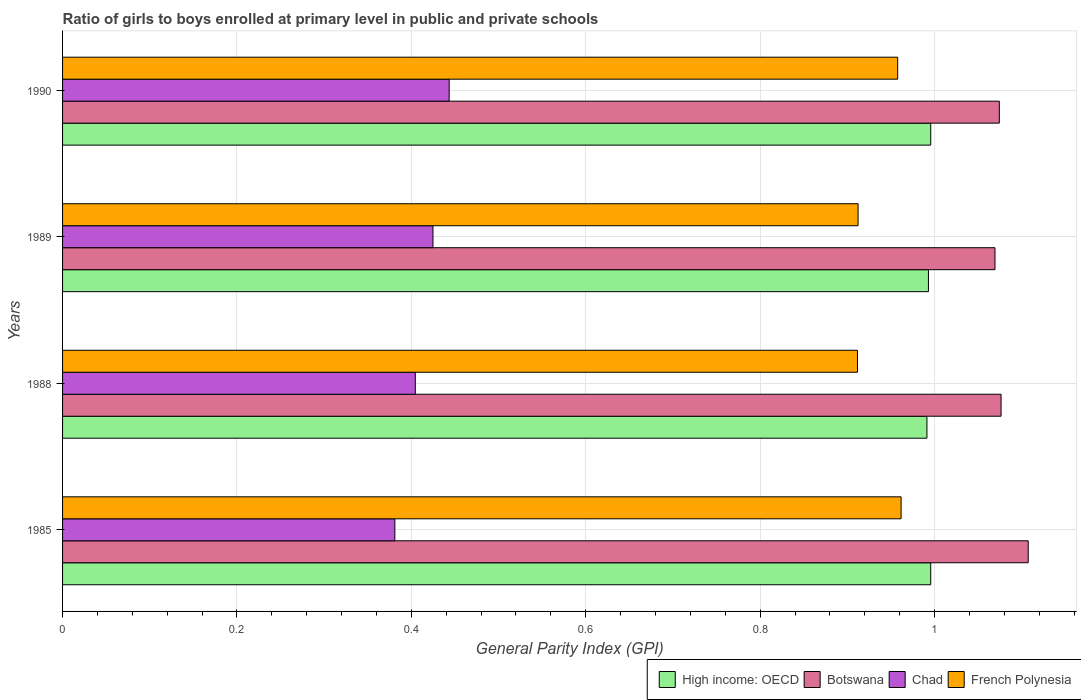How many different coloured bars are there?
Make the answer very short. 4. Are the number of bars per tick equal to the number of legend labels?
Offer a very short reply. Yes. Are the number of bars on each tick of the Y-axis equal?
Ensure brevity in your answer.  Yes. How many bars are there on the 1st tick from the bottom?
Provide a short and direct response. 4. In how many cases, is the number of bars for a given year not equal to the number of legend labels?
Make the answer very short. 0. What is the general parity index in Chad in 1985?
Provide a short and direct response. 0.38. Across all years, what is the maximum general parity index in Chad?
Give a very brief answer. 0.44. Across all years, what is the minimum general parity index in French Polynesia?
Offer a very short reply. 0.91. What is the total general parity index in Chad in the graph?
Make the answer very short. 1.65. What is the difference between the general parity index in Botswana in 1985 and that in 1990?
Provide a short and direct response. 0.03. What is the difference between the general parity index in Chad in 1988 and the general parity index in Botswana in 1985?
Your response must be concise. -0.7. What is the average general parity index in Botswana per year?
Offer a terse response. 1.08. In the year 1985, what is the difference between the general parity index in Botswana and general parity index in Chad?
Offer a terse response. 0.73. What is the ratio of the general parity index in Botswana in 1989 to that in 1990?
Provide a succinct answer. 1. What is the difference between the highest and the second highest general parity index in Chad?
Provide a short and direct response. 0.02. What is the difference between the highest and the lowest general parity index in French Polynesia?
Your answer should be very brief. 0.05. In how many years, is the general parity index in Botswana greater than the average general parity index in Botswana taken over all years?
Your response must be concise. 1. Is it the case that in every year, the sum of the general parity index in High income: OECD and general parity index in French Polynesia is greater than the sum of general parity index in Botswana and general parity index in Chad?
Make the answer very short. Yes. What does the 1st bar from the top in 1990 represents?
Provide a succinct answer. French Polynesia. What does the 4th bar from the bottom in 1989 represents?
Provide a succinct answer. French Polynesia. Is it the case that in every year, the sum of the general parity index in Chad and general parity index in Botswana is greater than the general parity index in High income: OECD?
Make the answer very short. Yes. Are all the bars in the graph horizontal?
Keep it short and to the point. Yes. What is the difference between two consecutive major ticks on the X-axis?
Your response must be concise. 0.2. Are the values on the major ticks of X-axis written in scientific E-notation?
Keep it short and to the point. No. Does the graph contain grids?
Give a very brief answer. Yes. Where does the legend appear in the graph?
Offer a very short reply. Bottom right. How many legend labels are there?
Your answer should be very brief. 4. What is the title of the graph?
Ensure brevity in your answer.  Ratio of girls to boys enrolled at primary level in public and private schools. Does "Macao" appear as one of the legend labels in the graph?
Your response must be concise. No. What is the label or title of the X-axis?
Your response must be concise. General Parity Index (GPI). What is the label or title of the Y-axis?
Give a very brief answer. Years. What is the General Parity Index (GPI) of High income: OECD in 1985?
Make the answer very short. 1. What is the General Parity Index (GPI) of Botswana in 1985?
Give a very brief answer. 1.11. What is the General Parity Index (GPI) of Chad in 1985?
Make the answer very short. 0.38. What is the General Parity Index (GPI) of French Polynesia in 1985?
Give a very brief answer. 0.96. What is the General Parity Index (GPI) of High income: OECD in 1988?
Your answer should be compact. 0.99. What is the General Parity Index (GPI) in Botswana in 1988?
Make the answer very short. 1.08. What is the General Parity Index (GPI) of Chad in 1988?
Provide a succinct answer. 0.4. What is the General Parity Index (GPI) in French Polynesia in 1988?
Make the answer very short. 0.91. What is the General Parity Index (GPI) of High income: OECD in 1989?
Your response must be concise. 0.99. What is the General Parity Index (GPI) in Botswana in 1989?
Your answer should be compact. 1.07. What is the General Parity Index (GPI) in Chad in 1989?
Keep it short and to the point. 0.42. What is the General Parity Index (GPI) of French Polynesia in 1989?
Offer a terse response. 0.91. What is the General Parity Index (GPI) of High income: OECD in 1990?
Your response must be concise. 1. What is the General Parity Index (GPI) of Botswana in 1990?
Offer a very short reply. 1.07. What is the General Parity Index (GPI) in Chad in 1990?
Offer a very short reply. 0.44. What is the General Parity Index (GPI) of French Polynesia in 1990?
Provide a short and direct response. 0.96. Across all years, what is the maximum General Parity Index (GPI) in High income: OECD?
Your answer should be compact. 1. Across all years, what is the maximum General Parity Index (GPI) of Botswana?
Provide a short and direct response. 1.11. Across all years, what is the maximum General Parity Index (GPI) in Chad?
Provide a short and direct response. 0.44. Across all years, what is the maximum General Parity Index (GPI) in French Polynesia?
Offer a terse response. 0.96. Across all years, what is the minimum General Parity Index (GPI) in High income: OECD?
Offer a terse response. 0.99. Across all years, what is the minimum General Parity Index (GPI) of Botswana?
Your answer should be very brief. 1.07. Across all years, what is the minimum General Parity Index (GPI) in Chad?
Give a very brief answer. 0.38. Across all years, what is the minimum General Parity Index (GPI) in French Polynesia?
Your answer should be very brief. 0.91. What is the total General Parity Index (GPI) of High income: OECD in the graph?
Give a very brief answer. 3.98. What is the total General Parity Index (GPI) in Botswana in the graph?
Offer a very short reply. 4.33. What is the total General Parity Index (GPI) of Chad in the graph?
Ensure brevity in your answer.  1.65. What is the total General Parity Index (GPI) in French Polynesia in the graph?
Your answer should be very brief. 3.74. What is the difference between the General Parity Index (GPI) in High income: OECD in 1985 and that in 1988?
Keep it short and to the point. 0. What is the difference between the General Parity Index (GPI) of Botswana in 1985 and that in 1988?
Your answer should be compact. 0.03. What is the difference between the General Parity Index (GPI) of Chad in 1985 and that in 1988?
Provide a short and direct response. -0.02. What is the difference between the General Parity Index (GPI) of French Polynesia in 1985 and that in 1988?
Keep it short and to the point. 0.05. What is the difference between the General Parity Index (GPI) in High income: OECD in 1985 and that in 1989?
Provide a succinct answer. 0. What is the difference between the General Parity Index (GPI) in Botswana in 1985 and that in 1989?
Your answer should be compact. 0.04. What is the difference between the General Parity Index (GPI) of Chad in 1985 and that in 1989?
Your response must be concise. -0.04. What is the difference between the General Parity Index (GPI) of French Polynesia in 1985 and that in 1989?
Make the answer very short. 0.05. What is the difference between the General Parity Index (GPI) in High income: OECD in 1985 and that in 1990?
Your answer should be compact. -0. What is the difference between the General Parity Index (GPI) in Botswana in 1985 and that in 1990?
Provide a short and direct response. 0.03. What is the difference between the General Parity Index (GPI) in Chad in 1985 and that in 1990?
Offer a very short reply. -0.06. What is the difference between the General Parity Index (GPI) of French Polynesia in 1985 and that in 1990?
Ensure brevity in your answer.  0. What is the difference between the General Parity Index (GPI) of High income: OECD in 1988 and that in 1989?
Your answer should be compact. -0. What is the difference between the General Parity Index (GPI) of Botswana in 1988 and that in 1989?
Ensure brevity in your answer.  0.01. What is the difference between the General Parity Index (GPI) of Chad in 1988 and that in 1989?
Your response must be concise. -0.02. What is the difference between the General Parity Index (GPI) of French Polynesia in 1988 and that in 1989?
Your answer should be compact. -0. What is the difference between the General Parity Index (GPI) in High income: OECD in 1988 and that in 1990?
Ensure brevity in your answer.  -0. What is the difference between the General Parity Index (GPI) of Botswana in 1988 and that in 1990?
Your response must be concise. 0. What is the difference between the General Parity Index (GPI) of Chad in 1988 and that in 1990?
Ensure brevity in your answer.  -0.04. What is the difference between the General Parity Index (GPI) in French Polynesia in 1988 and that in 1990?
Provide a short and direct response. -0.05. What is the difference between the General Parity Index (GPI) in High income: OECD in 1989 and that in 1990?
Make the answer very short. -0. What is the difference between the General Parity Index (GPI) in Botswana in 1989 and that in 1990?
Ensure brevity in your answer.  -0.01. What is the difference between the General Parity Index (GPI) of Chad in 1989 and that in 1990?
Make the answer very short. -0.02. What is the difference between the General Parity Index (GPI) in French Polynesia in 1989 and that in 1990?
Provide a succinct answer. -0.05. What is the difference between the General Parity Index (GPI) in High income: OECD in 1985 and the General Parity Index (GPI) in Botswana in 1988?
Offer a very short reply. -0.08. What is the difference between the General Parity Index (GPI) in High income: OECD in 1985 and the General Parity Index (GPI) in Chad in 1988?
Your response must be concise. 0.59. What is the difference between the General Parity Index (GPI) of High income: OECD in 1985 and the General Parity Index (GPI) of French Polynesia in 1988?
Your answer should be very brief. 0.08. What is the difference between the General Parity Index (GPI) in Botswana in 1985 and the General Parity Index (GPI) in Chad in 1988?
Your answer should be very brief. 0.7. What is the difference between the General Parity Index (GPI) in Botswana in 1985 and the General Parity Index (GPI) in French Polynesia in 1988?
Your response must be concise. 0.2. What is the difference between the General Parity Index (GPI) of Chad in 1985 and the General Parity Index (GPI) of French Polynesia in 1988?
Your response must be concise. -0.53. What is the difference between the General Parity Index (GPI) in High income: OECD in 1985 and the General Parity Index (GPI) in Botswana in 1989?
Make the answer very short. -0.07. What is the difference between the General Parity Index (GPI) of High income: OECD in 1985 and the General Parity Index (GPI) of Chad in 1989?
Give a very brief answer. 0.57. What is the difference between the General Parity Index (GPI) of High income: OECD in 1985 and the General Parity Index (GPI) of French Polynesia in 1989?
Your answer should be very brief. 0.08. What is the difference between the General Parity Index (GPI) in Botswana in 1985 and the General Parity Index (GPI) in Chad in 1989?
Provide a succinct answer. 0.68. What is the difference between the General Parity Index (GPI) of Botswana in 1985 and the General Parity Index (GPI) of French Polynesia in 1989?
Offer a terse response. 0.2. What is the difference between the General Parity Index (GPI) in Chad in 1985 and the General Parity Index (GPI) in French Polynesia in 1989?
Provide a short and direct response. -0.53. What is the difference between the General Parity Index (GPI) in High income: OECD in 1985 and the General Parity Index (GPI) in Botswana in 1990?
Keep it short and to the point. -0.08. What is the difference between the General Parity Index (GPI) in High income: OECD in 1985 and the General Parity Index (GPI) in Chad in 1990?
Provide a short and direct response. 0.55. What is the difference between the General Parity Index (GPI) of High income: OECD in 1985 and the General Parity Index (GPI) of French Polynesia in 1990?
Keep it short and to the point. 0.04. What is the difference between the General Parity Index (GPI) of Botswana in 1985 and the General Parity Index (GPI) of Chad in 1990?
Offer a terse response. 0.66. What is the difference between the General Parity Index (GPI) of Botswana in 1985 and the General Parity Index (GPI) of French Polynesia in 1990?
Your answer should be very brief. 0.15. What is the difference between the General Parity Index (GPI) in Chad in 1985 and the General Parity Index (GPI) in French Polynesia in 1990?
Offer a terse response. -0.58. What is the difference between the General Parity Index (GPI) of High income: OECD in 1988 and the General Parity Index (GPI) of Botswana in 1989?
Make the answer very short. -0.08. What is the difference between the General Parity Index (GPI) of High income: OECD in 1988 and the General Parity Index (GPI) of Chad in 1989?
Give a very brief answer. 0.57. What is the difference between the General Parity Index (GPI) in High income: OECD in 1988 and the General Parity Index (GPI) in French Polynesia in 1989?
Your answer should be very brief. 0.08. What is the difference between the General Parity Index (GPI) of Botswana in 1988 and the General Parity Index (GPI) of Chad in 1989?
Your answer should be very brief. 0.65. What is the difference between the General Parity Index (GPI) in Botswana in 1988 and the General Parity Index (GPI) in French Polynesia in 1989?
Offer a very short reply. 0.16. What is the difference between the General Parity Index (GPI) in Chad in 1988 and the General Parity Index (GPI) in French Polynesia in 1989?
Ensure brevity in your answer.  -0.51. What is the difference between the General Parity Index (GPI) of High income: OECD in 1988 and the General Parity Index (GPI) of Botswana in 1990?
Your answer should be very brief. -0.08. What is the difference between the General Parity Index (GPI) in High income: OECD in 1988 and the General Parity Index (GPI) in Chad in 1990?
Provide a succinct answer. 0.55. What is the difference between the General Parity Index (GPI) of High income: OECD in 1988 and the General Parity Index (GPI) of French Polynesia in 1990?
Provide a succinct answer. 0.03. What is the difference between the General Parity Index (GPI) in Botswana in 1988 and the General Parity Index (GPI) in Chad in 1990?
Keep it short and to the point. 0.63. What is the difference between the General Parity Index (GPI) in Botswana in 1988 and the General Parity Index (GPI) in French Polynesia in 1990?
Provide a succinct answer. 0.12. What is the difference between the General Parity Index (GPI) in Chad in 1988 and the General Parity Index (GPI) in French Polynesia in 1990?
Your answer should be compact. -0.55. What is the difference between the General Parity Index (GPI) in High income: OECD in 1989 and the General Parity Index (GPI) in Botswana in 1990?
Provide a short and direct response. -0.08. What is the difference between the General Parity Index (GPI) in High income: OECD in 1989 and the General Parity Index (GPI) in Chad in 1990?
Provide a succinct answer. 0.55. What is the difference between the General Parity Index (GPI) of High income: OECD in 1989 and the General Parity Index (GPI) of French Polynesia in 1990?
Provide a succinct answer. 0.04. What is the difference between the General Parity Index (GPI) of Botswana in 1989 and the General Parity Index (GPI) of Chad in 1990?
Your answer should be very brief. 0.63. What is the difference between the General Parity Index (GPI) of Botswana in 1989 and the General Parity Index (GPI) of French Polynesia in 1990?
Give a very brief answer. 0.11. What is the difference between the General Parity Index (GPI) of Chad in 1989 and the General Parity Index (GPI) of French Polynesia in 1990?
Give a very brief answer. -0.53. What is the average General Parity Index (GPI) in High income: OECD per year?
Your response must be concise. 0.99. What is the average General Parity Index (GPI) in Botswana per year?
Provide a succinct answer. 1.08. What is the average General Parity Index (GPI) in Chad per year?
Provide a short and direct response. 0.41. What is the average General Parity Index (GPI) in French Polynesia per year?
Offer a terse response. 0.94. In the year 1985, what is the difference between the General Parity Index (GPI) of High income: OECD and General Parity Index (GPI) of Botswana?
Offer a very short reply. -0.11. In the year 1985, what is the difference between the General Parity Index (GPI) of High income: OECD and General Parity Index (GPI) of Chad?
Offer a terse response. 0.61. In the year 1985, what is the difference between the General Parity Index (GPI) of High income: OECD and General Parity Index (GPI) of French Polynesia?
Make the answer very short. 0.03. In the year 1985, what is the difference between the General Parity Index (GPI) of Botswana and General Parity Index (GPI) of Chad?
Make the answer very short. 0.73. In the year 1985, what is the difference between the General Parity Index (GPI) in Botswana and General Parity Index (GPI) in French Polynesia?
Ensure brevity in your answer.  0.15. In the year 1985, what is the difference between the General Parity Index (GPI) of Chad and General Parity Index (GPI) of French Polynesia?
Your answer should be compact. -0.58. In the year 1988, what is the difference between the General Parity Index (GPI) of High income: OECD and General Parity Index (GPI) of Botswana?
Offer a terse response. -0.09. In the year 1988, what is the difference between the General Parity Index (GPI) of High income: OECD and General Parity Index (GPI) of Chad?
Ensure brevity in your answer.  0.59. In the year 1988, what is the difference between the General Parity Index (GPI) of High income: OECD and General Parity Index (GPI) of French Polynesia?
Offer a terse response. 0.08. In the year 1988, what is the difference between the General Parity Index (GPI) in Botswana and General Parity Index (GPI) in Chad?
Keep it short and to the point. 0.67. In the year 1988, what is the difference between the General Parity Index (GPI) of Botswana and General Parity Index (GPI) of French Polynesia?
Your answer should be very brief. 0.16. In the year 1988, what is the difference between the General Parity Index (GPI) in Chad and General Parity Index (GPI) in French Polynesia?
Your answer should be very brief. -0.51. In the year 1989, what is the difference between the General Parity Index (GPI) of High income: OECD and General Parity Index (GPI) of Botswana?
Your response must be concise. -0.08. In the year 1989, what is the difference between the General Parity Index (GPI) of High income: OECD and General Parity Index (GPI) of Chad?
Provide a succinct answer. 0.57. In the year 1989, what is the difference between the General Parity Index (GPI) in High income: OECD and General Parity Index (GPI) in French Polynesia?
Your answer should be very brief. 0.08. In the year 1989, what is the difference between the General Parity Index (GPI) of Botswana and General Parity Index (GPI) of Chad?
Provide a short and direct response. 0.64. In the year 1989, what is the difference between the General Parity Index (GPI) of Botswana and General Parity Index (GPI) of French Polynesia?
Offer a terse response. 0.16. In the year 1989, what is the difference between the General Parity Index (GPI) in Chad and General Parity Index (GPI) in French Polynesia?
Your answer should be compact. -0.49. In the year 1990, what is the difference between the General Parity Index (GPI) of High income: OECD and General Parity Index (GPI) of Botswana?
Make the answer very short. -0.08. In the year 1990, what is the difference between the General Parity Index (GPI) of High income: OECD and General Parity Index (GPI) of Chad?
Offer a very short reply. 0.55. In the year 1990, what is the difference between the General Parity Index (GPI) in High income: OECD and General Parity Index (GPI) in French Polynesia?
Make the answer very short. 0.04. In the year 1990, what is the difference between the General Parity Index (GPI) of Botswana and General Parity Index (GPI) of Chad?
Offer a very short reply. 0.63. In the year 1990, what is the difference between the General Parity Index (GPI) in Botswana and General Parity Index (GPI) in French Polynesia?
Provide a succinct answer. 0.12. In the year 1990, what is the difference between the General Parity Index (GPI) of Chad and General Parity Index (GPI) of French Polynesia?
Offer a terse response. -0.51. What is the ratio of the General Parity Index (GPI) in High income: OECD in 1985 to that in 1988?
Offer a terse response. 1. What is the ratio of the General Parity Index (GPI) of Botswana in 1985 to that in 1988?
Give a very brief answer. 1.03. What is the ratio of the General Parity Index (GPI) of Chad in 1985 to that in 1988?
Your response must be concise. 0.94. What is the ratio of the General Parity Index (GPI) of French Polynesia in 1985 to that in 1988?
Provide a short and direct response. 1.05. What is the ratio of the General Parity Index (GPI) in Botswana in 1985 to that in 1989?
Ensure brevity in your answer.  1.04. What is the ratio of the General Parity Index (GPI) of Chad in 1985 to that in 1989?
Offer a terse response. 0.9. What is the ratio of the General Parity Index (GPI) in French Polynesia in 1985 to that in 1989?
Give a very brief answer. 1.05. What is the ratio of the General Parity Index (GPI) in Botswana in 1985 to that in 1990?
Keep it short and to the point. 1.03. What is the ratio of the General Parity Index (GPI) in Chad in 1985 to that in 1990?
Your response must be concise. 0.86. What is the ratio of the General Parity Index (GPI) in Botswana in 1988 to that in 1989?
Make the answer very short. 1.01. What is the ratio of the General Parity Index (GPI) in Botswana in 1988 to that in 1990?
Your answer should be very brief. 1. What is the ratio of the General Parity Index (GPI) of Chad in 1988 to that in 1990?
Make the answer very short. 0.91. What is the ratio of the General Parity Index (GPI) of French Polynesia in 1988 to that in 1990?
Provide a succinct answer. 0.95. What is the ratio of the General Parity Index (GPI) of High income: OECD in 1989 to that in 1990?
Ensure brevity in your answer.  1. What is the ratio of the General Parity Index (GPI) of Botswana in 1989 to that in 1990?
Make the answer very short. 1. What is the ratio of the General Parity Index (GPI) of Chad in 1989 to that in 1990?
Offer a terse response. 0.96. What is the ratio of the General Parity Index (GPI) of French Polynesia in 1989 to that in 1990?
Your answer should be compact. 0.95. What is the difference between the highest and the second highest General Parity Index (GPI) of High income: OECD?
Your answer should be compact. 0. What is the difference between the highest and the second highest General Parity Index (GPI) in Botswana?
Give a very brief answer. 0.03. What is the difference between the highest and the second highest General Parity Index (GPI) in Chad?
Offer a terse response. 0.02. What is the difference between the highest and the second highest General Parity Index (GPI) in French Polynesia?
Make the answer very short. 0. What is the difference between the highest and the lowest General Parity Index (GPI) in High income: OECD?
Your answer should be very brief. 0. What is the difference between the highest and the lowest General Parity Index (GPI) in Botswana?
Keep it short and to the point. 0.04. What is the difference between the highest and the lowest General Parity Index (GPI) in Chad?
Offer a terse response. 0.06. 